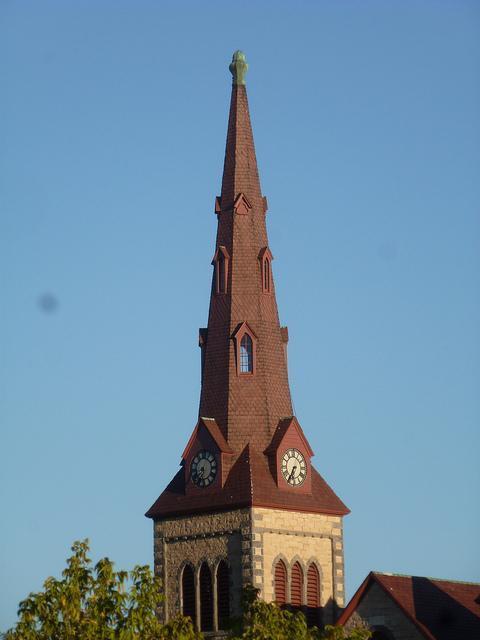How many clock faces are there?
Give a very brief answer. 2. How many skis is the man wearing?
Give a very brief answer. 0. 